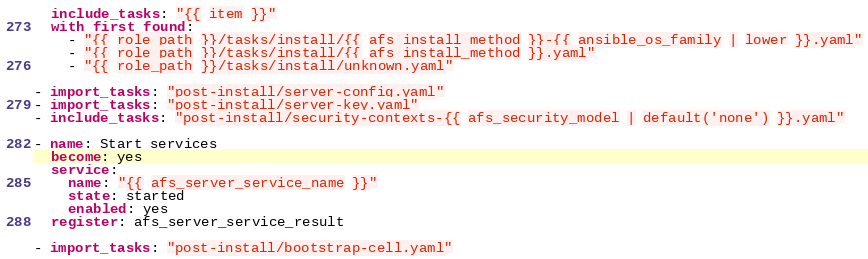<code> <loc_0><loc_0><loc_500><loc_500><_YAML_>  include_tasks: "{{ item }}"
  with_first_found:
    - "{{ role_path }}/tasks/install/{{ afs_install_method }}-{{ ansible_os_family | lower }}.yaml"
    - "{{ role_path }}/tasks/install/{{ afs_install_method }}.yaml"
    - "{{ role_path }}/tasks/install/unknown.yaml"

- import_tasks: "post-install/server-config.yaml"
- import_tasks: "post-install/server-key.yaml"
- include_tasks: "post-install/security-contexts-{{ afs_security_model | default('none') }}.yaml"

- name: Start services
  become: yes
  service:
    name: "{{ afs_server_service_name }}"
    state: started
    enabled: yes
  register: afs_server_service_result

- import_tasks: "post-install/bootstrap-cell.yaml"
</code> 